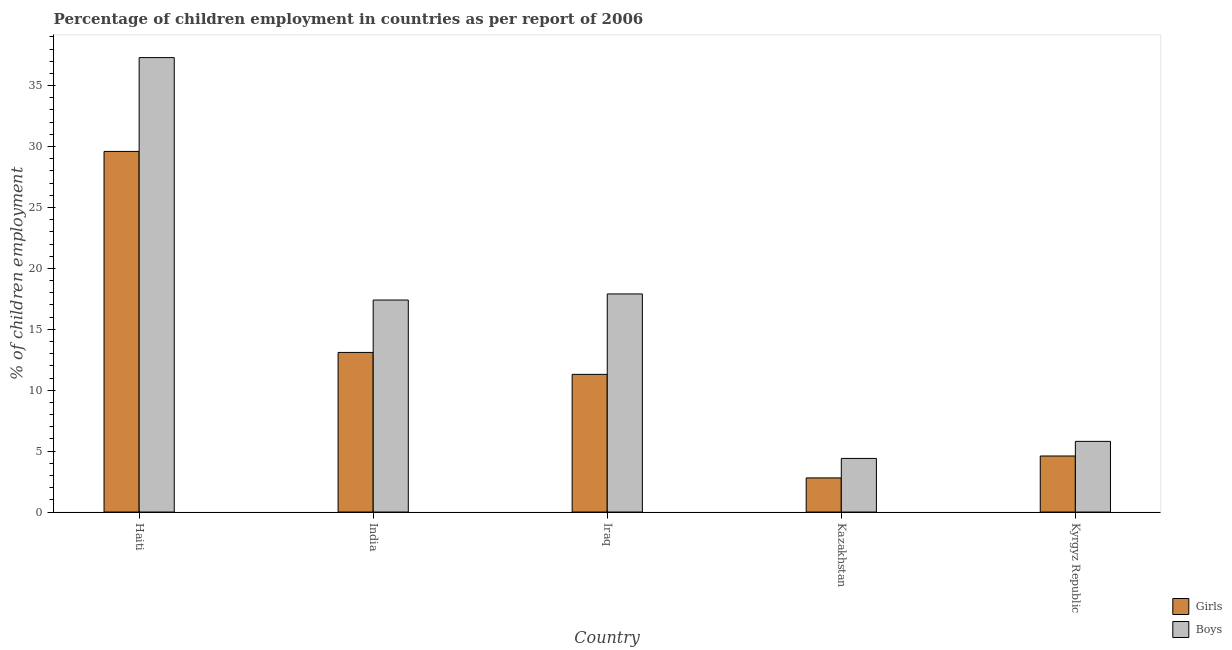How many different coloured bars are there?
Keep it short and to the point. 2. How many groups of bars are there?
Keep it short and to the point. 5. Are the number of bars per tick equal to the number of legend labels?
Keep it short and to the point. Yes. What is the label of the 1st group of bars from the left?
Provide a short and direct response. Haiti. Across all countries, what is the maximum percentage of employed boys?
Your answer should be very brief. 37.3. Across all countries, what is the minimum percentage of employed boys?
Provide a short and direct response. 4.4. In which country was the percentage of employed girls maximum?
Your answer should be compact. Haiti. In which country was the percentage of employed boys minimum?
Your response must be concise. Kazakhstan. What is the total percentage of employed boys in the graph?
Offer a terse response. 82.8. What is the difference between the percentage of employed girls in Kazakhstan and the percentage of employed boys in India?
Provide a succinct answer. -14.6. What is the average percentage of employed girls per country?
Provide a short and direct response. 12.28. What is the difference between the percentage of employed girls and percentage of employed boys in India?
Keep it short and to the point. -4.3. What is the ratio of the percentage of employed boys in Haiti to that in Kyrgyz Republic?
Keep it short and to the point. 6.43. What is the difference between the highest and the lowest percentage of employed boys?
Give a very brief answer. 32.9. Is the sum of the percentage of employed boys in India and Iraq greater than the maximum percentage of employed girls across all countries?
Keep it short and to the point. Yes. What does the 2nd bar from the left in Haiti represents?
Provide a succinct answer. Boys. What does the 2nd bar from the right in Kyrgyz Republic represents?
Your answer should be compact. Girls. How many bars are there?
Your response must be concise. 10. Are all the bars in the graph horizontal?
Make the answer very short. No. How many countries are there in the graph?
Your answer should be compact. 5. What is the difference between two consecutive major ticks on the Y-axis?
Offer a terse response. 5. Does the graph contain any zero values?
Your answer should be very brief. No. How many legend labels are there?
Provide a succinct answer. 2. How are the legend labels stacked?
Give a very brief answer. Vertical. What is the title of the graph?
Offer a very short reply. Percentage of children employment in countries as per report of 2006. Does "Official creditors" appear as one of the legend labels in the graph?
Your answer should be very brief. No. What is the label or title of the X-axis?
Your answer should be compact. Country. What is the label or title of the Y-axis?
Keep it short and to the point. % of children employment. What is the % of children employment in Girls in Haiti?
Give a very brief answer. 29.6. What is the % of children employment of Boys in Haiti?
Offer a very short reply. 37.3. What is the % of children employment in Boys in India?
Offer a very short reply. 17.4. What is the % of children employment in Girls in Kazakhstan?
Provide a short and direct response. 2.8. What is the % of children employment in Boys in Kazakhstan?
Your answer should be compact. 4.4. What is the % of children employment of Boys in Kyrgyz Republic?
Offer a terse response. 5.8. Across all countries, what is the maximum % of children employment of Girls?
Provide a short and direct response. 29.6. Across all countries, what is the maximum % of children employment of Boys?
Offer a terse response. 37.3. Across all countries, what is the minimum % of children employment in Girls?
Give a very brief answer. 2.8. Across all countries, what is the minimum % of children employment in Boys?
Your response must be concise. 4.4. What is the total % of children employment in Girls in the graph?
Ensure brevity in your answer.  61.4. What is the total % of children employment in Boys in the graph?
Offer a very short reply. 82.8. What is the difference between the % of children employment in Girls in Haiti and that in India?
Ensure brevity in your answer.  16.5. What is the difference between the % of children employment in Boys in Haiti and that in Iraq?
Your answer should be compact. 19.4. What is the difference between the % of children employment in Girls in Haiti and that in Kazakhstan?
Offer a terse response. 26.8. What is the difference between the % of children employment of Boys in Haiti and that in Kazakhstan?
Your answer should be very brief. 32.9. What is the difference between the % of children employment of Girls in Haiti and that in Kyrgyz Republic?
Ensure brevity in your answer.  25. What is the difference between the % of children employment in Boys in Haiti and that in Kyrgyz Republic?
Your answer should be compact. 31.5. What is the difference between the % of children employment of Boys in India and that in Iraq?
Offer a very short reply. -0.5. What is the difference between the % of children employment of Girls in India and that in Kazakhstan?
Give a very brief answer. 10.3. What is the difference between the % of children employment in Boys in India and that in Kazakhstan?
Your answer should be very brief. 13. What is the difference between the % of children employment of Girls in India and that in Kyrgyz Republic?
Keep it short and to the point. 8.5. What is the difference between the % of children employment of Boys in India and that in Kyrgyz Republic?
Provide a short and direct response. 11.6. What is the difference between the % of children employment of Boys in Iraq and that in Kazakhstan?
Provide a short and direct response. 13.5. What is the difference between the % of children employment in Girls in Iraq and that in Kyrgyz Republic?
Your answer should be compact. 6.7. What is the difference between the % of children employment in Boys in Iraq and that in Kyrgyz Republic?
Provide a short and direct response. 12.1. What is the difference between the % of children employment in Girls in Kazakhstan and that in Kyrgyz Republic?
Your response must be concise. -1.8. What is the difference between the % of children employment in Girls in Haiti and the % of children employment in Boys in India?
Provide a short and direct response. 12.2. What is the difference between the % of children employment in Girls in Haiti and the % of children employment in Boys in Iraq?
Provide a succinct answer. 11.7. What is the difference between the % of children employment in Girls in Haiti and the % of children employment in Boys in Kazakhstan?
Offer a terse response. 25.2. What is the difference between the % of children employment in Girls in Haiti and the % of children employment in Boys in Kyrgyz Republic?
Offer a terse response. 23.8. What is the difference between the % of children employment in Girls in India and the % of children employment in Boys in Kyrgyz Republic?
Your answer should be very brief. 7.3. What is the difference between the % of children employment of Girls in Iraq and the % of children employment of Boys in Kyrgyz Republic?
Provide a short and direct response. 5.5. What is the average % of children employment of Girls per country?
Provide a succinct answer. 12.28. What is the average % of children employment in Boys per country?
Your answer should be very brief. 16.56. What is the difference between the % of children employment in Girls and % of children employment in Boys in Haiti?
Keep it short and to the point. -7.7. What is the difference between the % of children employment in Girls and % of children employment in Boys in India?
Make the answer very short. -4.3. What is the difference between the % of children employment of Girls and % of children employment of Boys in Iraq?
Make the answer very short. -6.6. What is the ratio of the % of children employment in Girls in Haiti to that in India?
Make the answer very short. 2.26. What is the ratio of the % of children employment of Boys in Haiti to that in India?
Your answer should be very brief. 2.14. What is the ratio of the % of children employment of Girls in Haiti to that in Iraq?
Offer a very short reply. 2.62. What is the ratio of the % of children employment in Boys in Haiti to that in Iraq?
Provide a short and direct response. 2.08. What is the ratio of the % of children employment in Girls in Haiti to that in Kazakhstan?
Your answer should be compact. 10.57. What is the ratio of the % of children employment of Boys in Haiti to that in Kazakhstan?
Give a very brief answer. 8.48. What is the ratio of the % of children employment of Girls in Haiti to that in Kyrgyz Republic?
Your response must be concise. 6.43. What is the ratio of the % of children employment in Boys in Haiti to that in Kyrgyz Republic?
Your answer should be very brief. 6.43. What is the ratio of the % of children employment in Girls in India to that in Iraq?
Make the answer very short. 1.16. What is the ratio of the % of children employment of Boys in India to that in Iraq?
Your response must be concise. 0.97. What is the ratio of the % of children employment in Girls in India to that in Kazakhstan?
Make the answer very short. 4.68. What is the ratio of the % of children employment in Boys in India to that in Kazakhstan?
Keep it short and to the point. 3.95. What is the ratio of the % of children employment of Girls in India to that in Kyrgyz Republic?
Your answer should be compact. 2.85. What is the ratio of the % of children employment in Girls in Iraq to that in Kazakhstan?
Give a very brief answer. 4.04. What is the ratio of the % of children employment in Boys in Iraq to that in Kazakhstan?
Provide a short and direct response. 4.07. What is the ratio of the % of children employment of Girls in Iraq to that in Kyrgyz Republic?
Offer a terse response. 2.46. What is the ratio of the % of children employment in Boys in Iraq to that in Kyrgyz Republic?
Provide a short and direct response. 3.09. What is the ratio of the % of children employment of Girls in Kazakhstan to that in Kyrgyz Republic?
Ensure brevity in your answer.  0.61. What is the ratio of the % of children employment in Boys in Kazakhstan to that in Kyrgyz Republic?
Offer a terse response. 0.76. What is the difference between the highest and the second highest % of children employment in Boys?
Give a very brief answer. 19.4. What is the difference between the highest and the lowest % of children employment of Girls?
Provide a short and direct response. 26.8. What is the difference between the highest and the lowest % of children employment of Boys?
Ensure brevity in your answer.  32.9. 